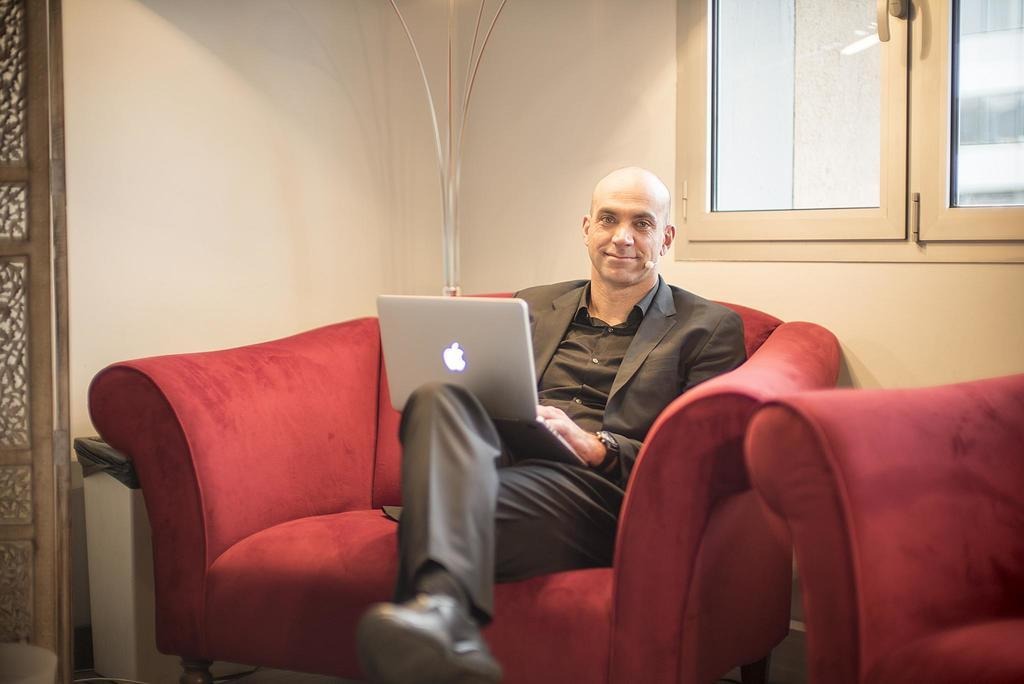What is the color of the wall in the image? The wall in the image is white. What can be seen on the wall in the image? There are windows on the wall in the image. What piece of furniture is in the image? There is a sofa in the image. What is the man in the image doing? A: The man is sitting on the sofa. What is the man holding in his hands? The man is holding a laptop in his hands. Can you see any nails on the wall in the image? There are no nails visible on the wall in the image. Is the man walking along the coast in the image? There is no coast visible in the image, and the man is sitting on the sofa, not walking. 